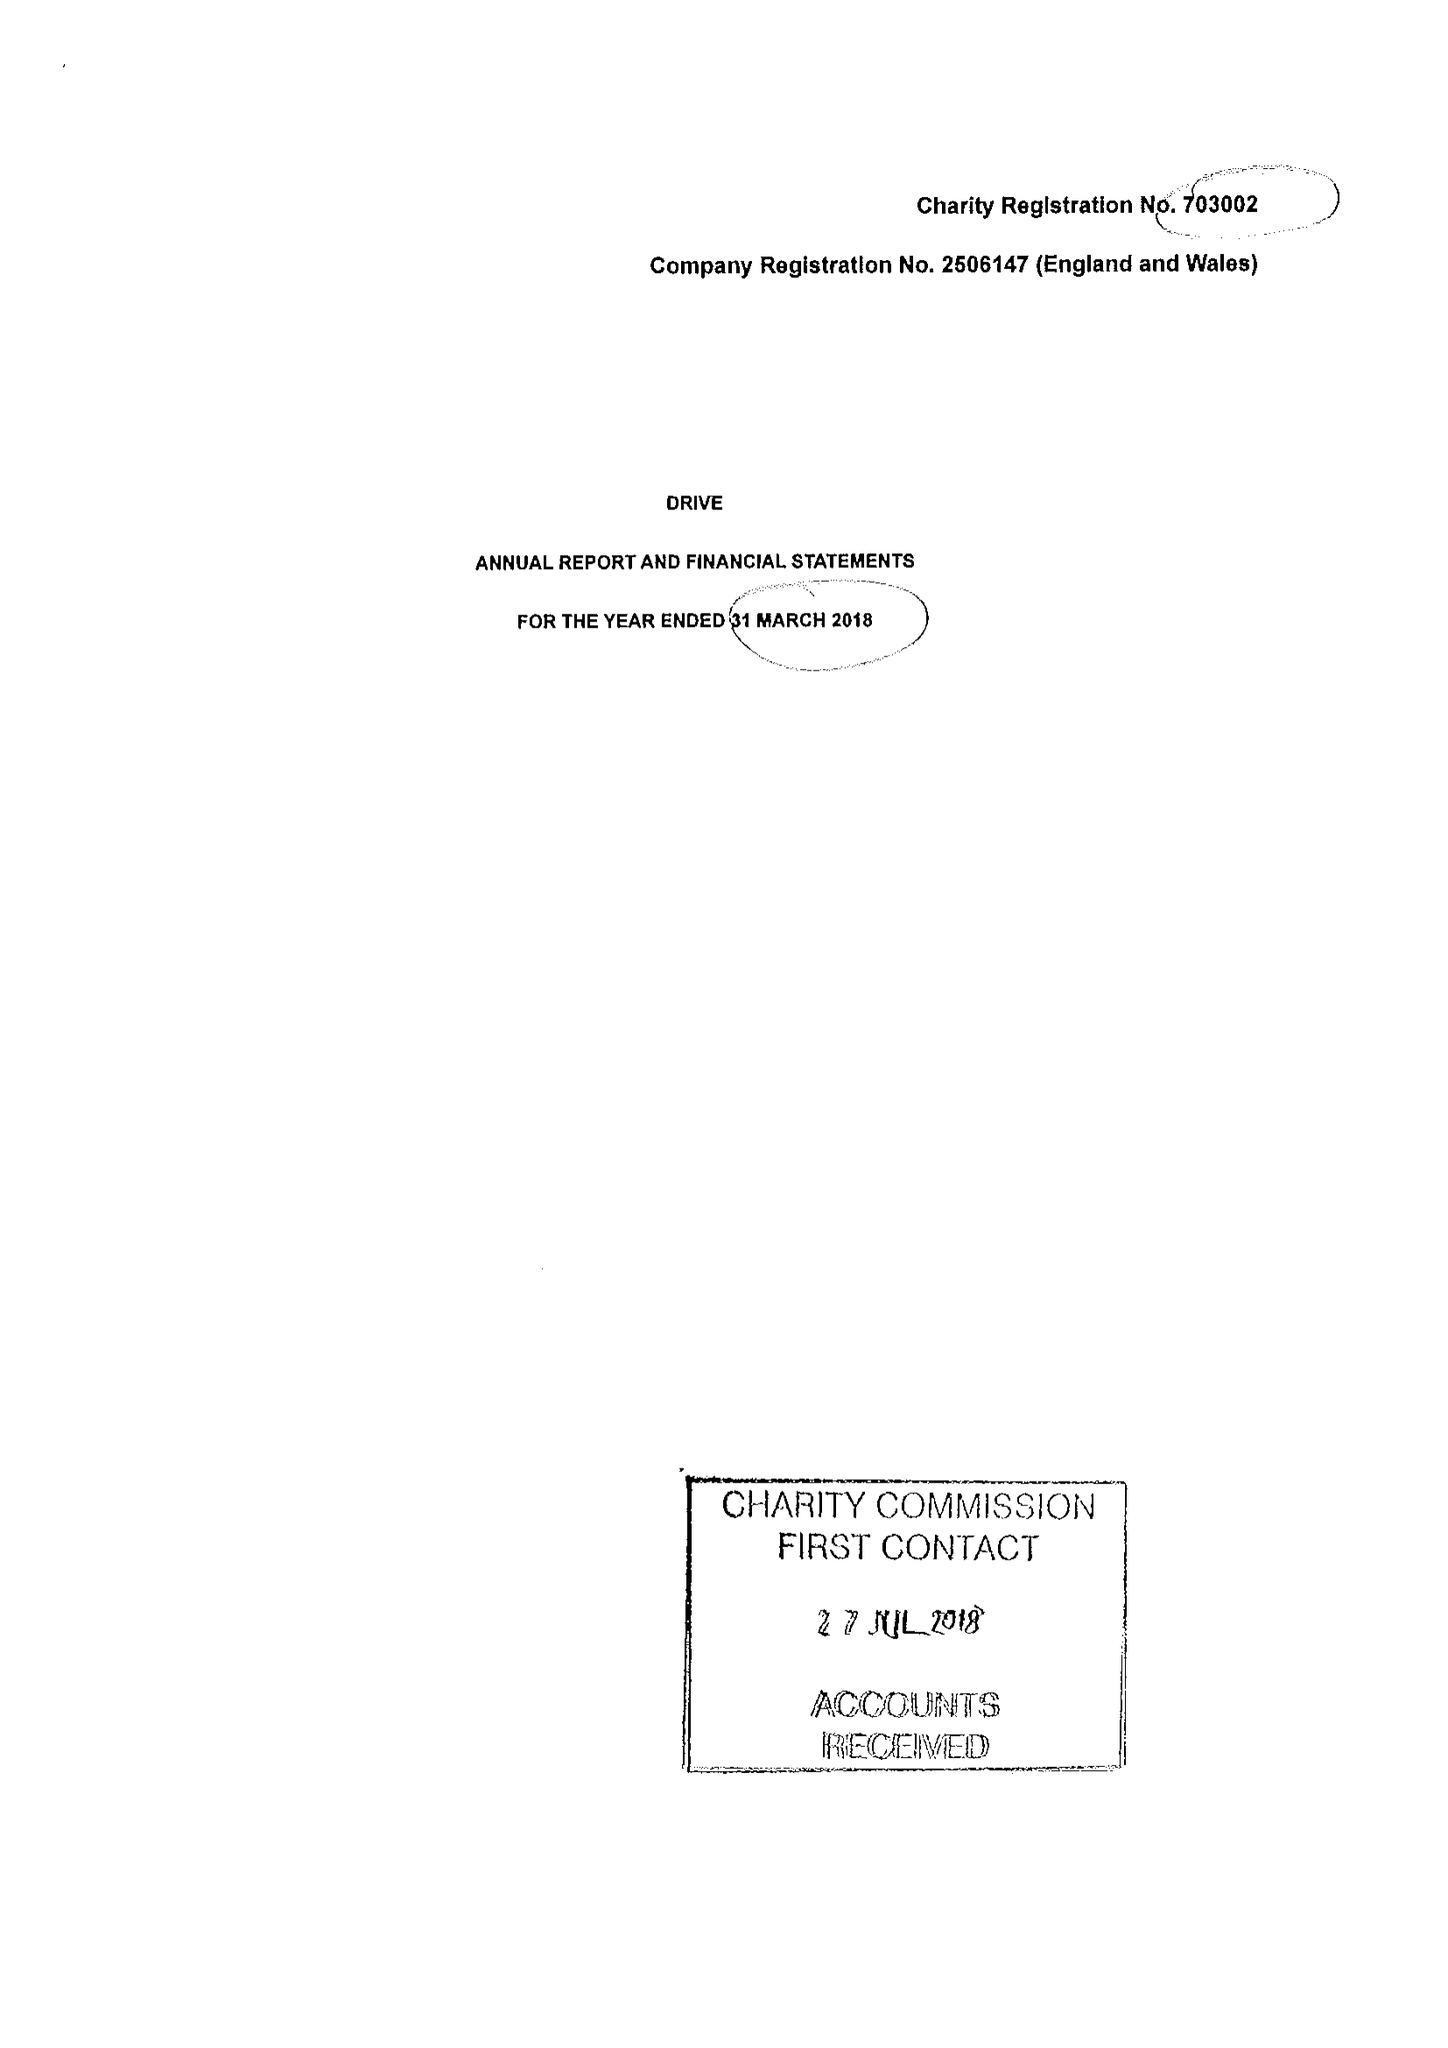What is the value for the charity_number?
Answer the question using a single word or phrase. 703002 